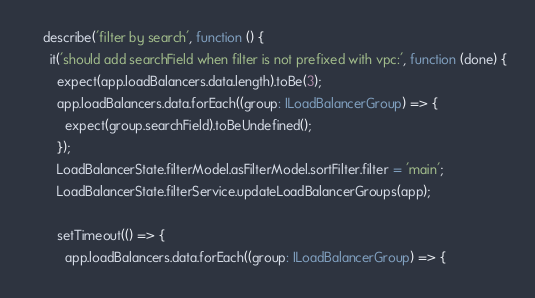Convert code to text. <code><loc_0><loc_0><loc_500><loc_500><_TypeScript_>
    describe('filter by search', function () {
      it('should add searchField when filter is not prefixed with vpc:', function (done) {
        expect(app.loadBalancers.data.length).toBe(3);
        app.loadBalancers.data.forEach((group: ILoadBalancerGroup) => {
          expect(group.searchField).toBeUndefined();
        });
        LoadBalancerState.filterModel.asFilterModel.sortFilter.filter = 'main';
        LoadBalancerState.filterService.updateLoadBalancerGroups(app);

        setTimeout(() => {
          app.loadBalancers.data.forEach((group: ILoadBalancerGroup) => {</code> 